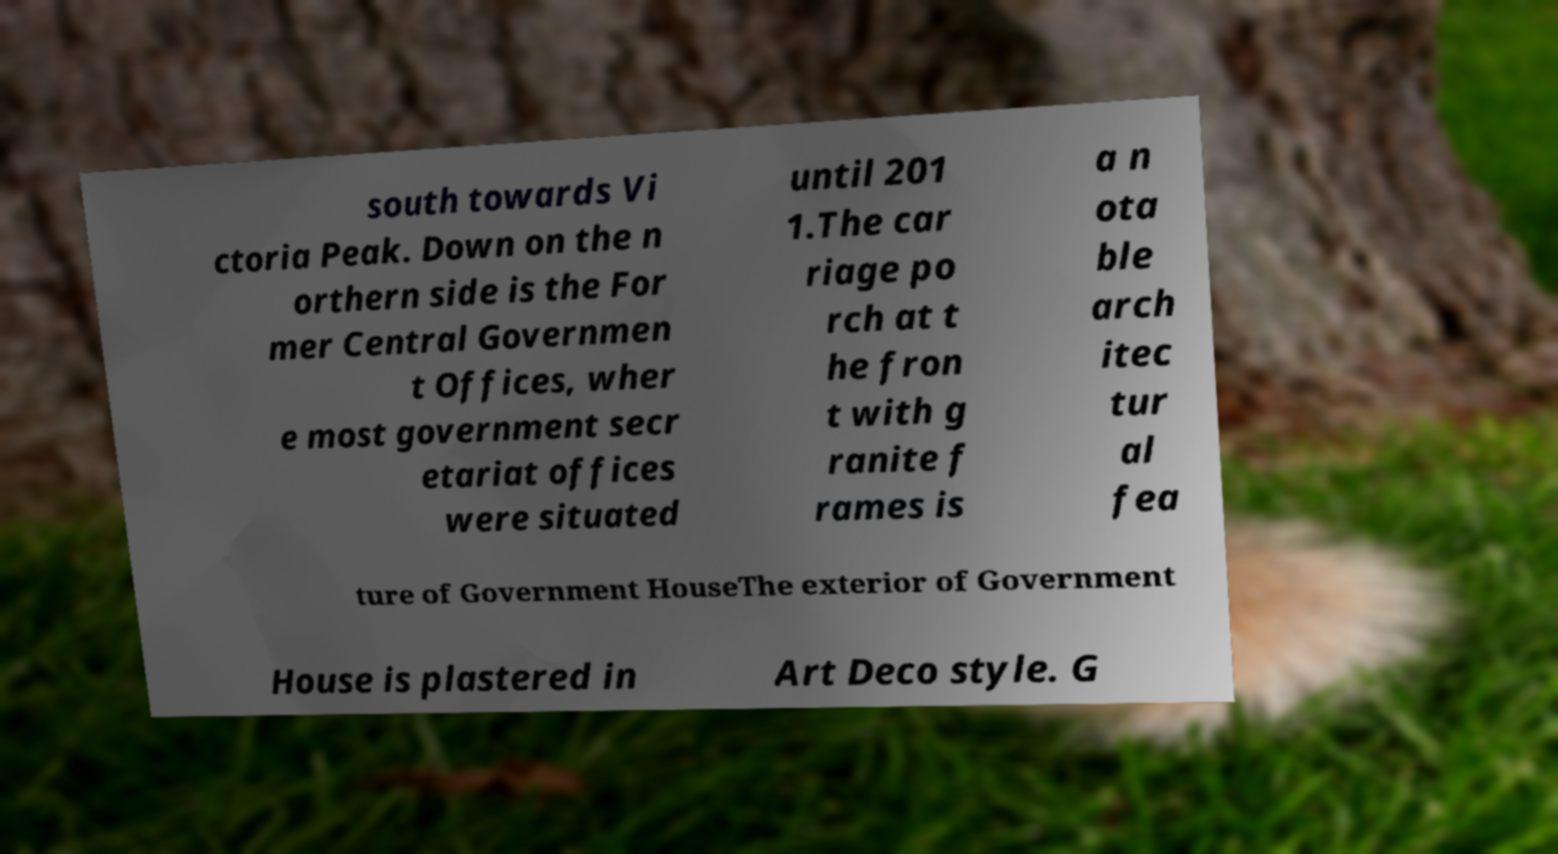Please identify and transcribe the text found in this image. south towards Vi ctoria Peak. Down on the n orthern side is the For mer Central Governmen t Offices, wher e most government secr etariat offices were situated until 201 1.The car riage po rch at t he fron t with g ranite f rames is a n ota ble arch itec tur al fea ture of Government HouseThe exterior of Government House is plastered in Art Deco style. G 